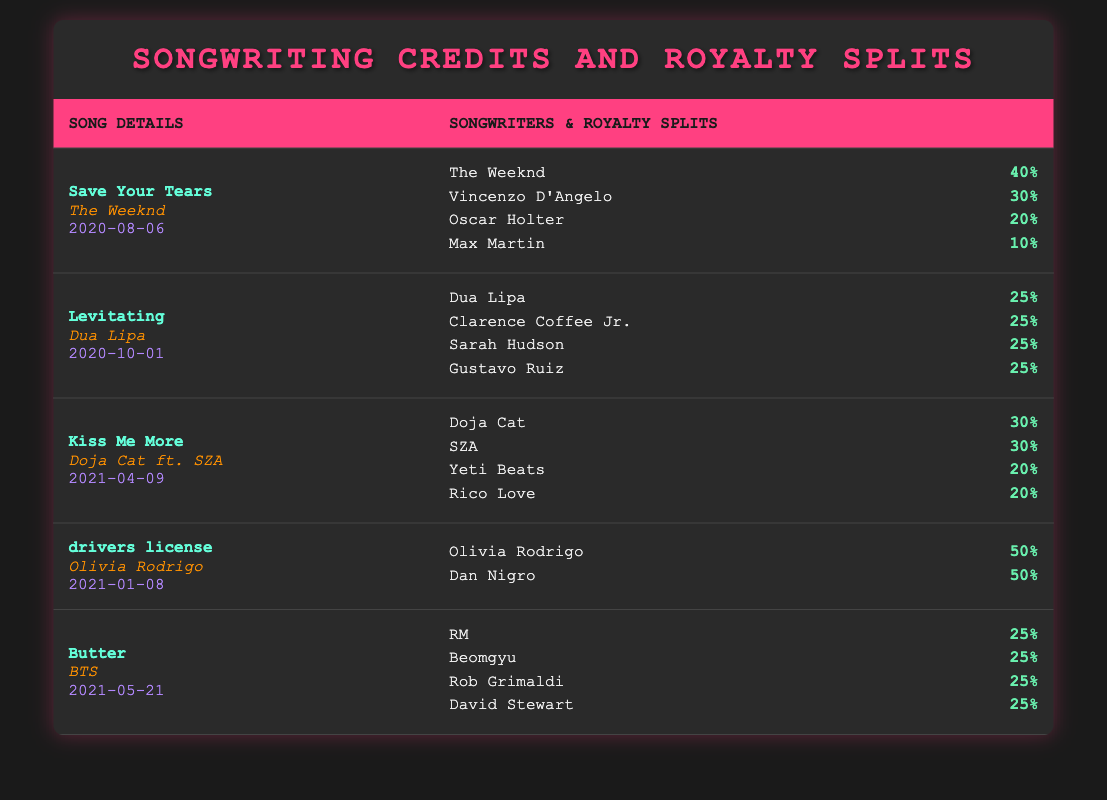What is the royalty split for Olivia Rodrigo in "drivers license"? The table shows that Olivia Rodrigo has a royalty split of 50%.
Answer: 50% Which song was released on April 9, 2021? The table indicates that "Kiss Me More" by Doja Cat ft. SZA was released on April 9, 2021.
Answer: Kiss Me More How many songwriters contributed to the song "Levitating"? The table lists four songwriters for "Levitating": Dua Lipa, Clarence Coffee Jr., Sarah Hudson, and Gustavo Ruiz.
Answer: 4 What is the total royalty percentage of songwriters for "Butter"? The song "Butter" has four songwriters, each with a royalty split of 25%. Therefore, the total is 25 + 25 + 25 + 25 = 100%.
Answer: 100% Is it true that every songwriter for "Levitating" has the same royalty split? Yes, the table shows that each of the four songwriters for "Levitating" has a split of 25%.
Answer: Yes Which artist has the highest individual royalty split in the provided data? "drivers license" has Olivia Rodrigo with a split of 50%, which is the highest individual split among the listed songs.
Answer: Olivia Rodrigo What is the average royalty split of the songwriters for "Kiss Me More"? "Kiss Me More" has four songwriters with splits of 30, 30, 20, and 20. The average is (30 + 30 + 20 + 20) / 4 = 25%.
Answer: 25% Were there any songs with more than two songwriters? Yes, songs like "Levitating" and "Butter" had four songwriters each.
Answer: Yes What percentage did Max Martin receive for "Save Your Tears"? Max Martin received a 10% royalty split for "Save Your Tears".
Answer: 10% 